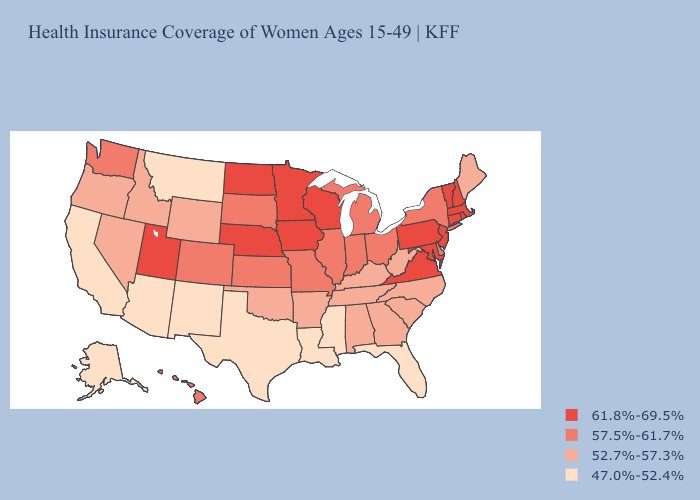What is the highest value in states that border Oklahoma?
Write a very short answer. 57.5%-61.7%. Among the states that border Nebraska , does Kansas have the lowest value?
Write a very short answer. No. Name the states that have a value in the range 47.0%-52.4%?
Concise answer only. Alaska, Arizona, California, Florida, Louisiana, Mississippi, Montana, New Mexico, Texas. Name the states that have a value in the range 47.0%-52.4%?
Be succinct. Alaska, Arizona, California, Florida, Louisiana, Mississippi, Montana, New Mexico, Texas. Does Pennsylvania have a higher value than Tennessee?
Answer briefly. Yes. What is the highest value in the MidWest ?
Quick response, please. 61.8%-69.5%. Does Rhode Island have a lower value than Arkansas?
Write a very short answer. No. What is the value of Oregon?
Keep it brief. 52.7%-57.3%. How many symbols are there in the legend?
Keep it brief. 4. What is the lowest value in the USA?
Keep it brief. 47.0%-52.4%. What is the lowest value in states that border Missouri?
Short answer required. 52.7%-57.3%. Name the states that have a value in the range 47.0%-52.4%?
Quick response, please. Alaska, Arizona, California, Florida, Louisiana, Mississippi, Montana, New Mexico, Texas. Which states have the lowest value in the MidWest?
Short answer required. Illinois, Indiana, Kansas, Michigan, Missouri, Ohio, South Dakota. Among the states that border New Mexico , which have the highest value?
Be succinct. Utah. 